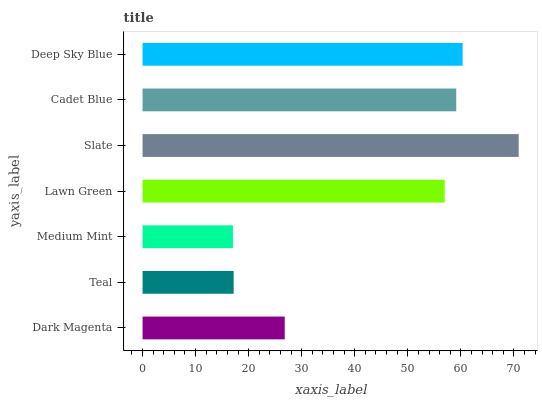Is Medium Mint the minimum?
Answer yes or no. Yes. Is Slate the maximum?
Answer yes or no. Yes. Is Teal the minimum?
Answer yes or no. No. Is Teal the maximum?
Answer yes or no. No. Is Dark Magenta greater than Teal?
Answer yes or no. Yes. Is Teal less than Dark Magenta?
Answer yes or no. Yes. Is Teal greater than Dark Magenta?
Answer yes or no. No. Is Dark Magenta less than Teal?
Answer yes or no. No. Is Lawn Green the high median?
Answer yes or no. Yes. Is Lawn Green the low median?
Answer yes or no. Yes. Is Teal the high median?
Answer yes or no. No. Is Cadet Blue the low median?
Answer yes or no. No. 